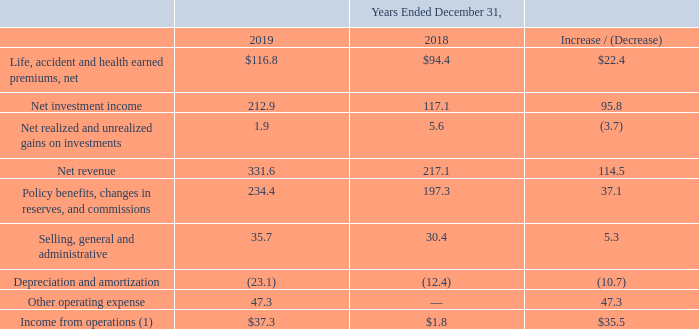Insurance Segment
(1) The Insurance segment revenues are inclusive of realized and unrealized gains and net investment income for the year ended December 31, 2019 and 2018. Such adjustments are related to transactions between entities under common control which are eliminated or are reclassified in consolidation.
Life, accident and health earned premiums, net: Life, accident and health earned premiums, net from our Insurance segment for the year ended December 31, 2019 increased $22.4 million to $116.8 million from $94.4 million for the year ended December 31, 2018. The increase was primarily due to the premiums generated from the acquisition of KIC in 2018.
Net investment income: Net investment income from our Insurance segment for the year ended December 31, 2019 increased $95.8 million to $212.9 million from $117.1 million for the year ended December 31, 2018. The increase was primarily due to the income generated from the assets acquired in the KIC acquisition, higher average invested assets as a result of the reinvestment of premiums and investment income received, and to a lesser extent, rotation into higher-yielding investments.
Net realized and unrealized gains on investments: Net realized and unrealized gains on investments from our Insurance segment for the year ended December 31, 2019 decreased $3.7 million to $1.9 million from $5.6 million for the year ended December 31, 2018. The decrease was driven by smaller realized gains on bonds and common stocks, higher impairments, and losses on fair value changes on interest only bonds in 2019. The decrease was offset by overall improvement in fair value changes in equity securities and realized gains on mortgage loans in 2019.
What was the life, accident and health earned premiums in December 2019? $116.8 million. What was the net investment income in December 2019? $212.9 million. What was the net realized and unrealized gain on investment in December 2019? $1.9 million. What was the percentage increase / (decrease) in the Life, accident and health earned premiums, net from 2018 to 2019?
Answer scale should be: percent. 116.8 / 94.4 - 1
Answer: 23.73. What is the average net investment income?
Answer scale should be: million. (212.9 + 117.1) / 2
Answer: 165. What is the percentage increase / (decrease) in the Net revenue from 2018 to 2019?
Answer scale should be: percent. 331.6 / 217.1 - 1
Answer: 52.74. 